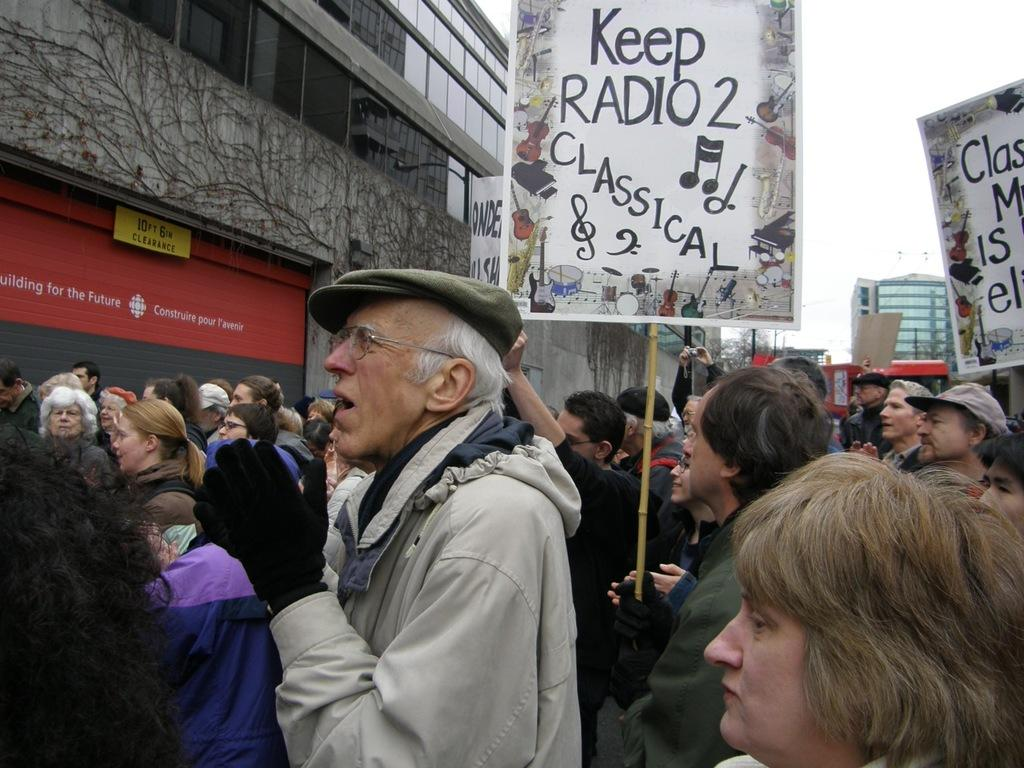Who or what can be seen in the image? There are persons in the image. What are the name boards used for in the image? The name boards are used to identify or label something or someone in the image. Can you describe the other objects in the image? There are other objects in the image, but their specific details are not mentioned in the provided facts. What can be seen in the background of the image? There are buildings, a name board, and sky visible in the background of the image. What other objects can be seen in the background of the image? There are other objects in the background of the image, but their specific details are not mentioned in the provided facts. What is the profit margin of the credit card company mentioned on the name board in the image? There is no information about a credit card company or profit margin in the image, so it cannot be determined from the image. 